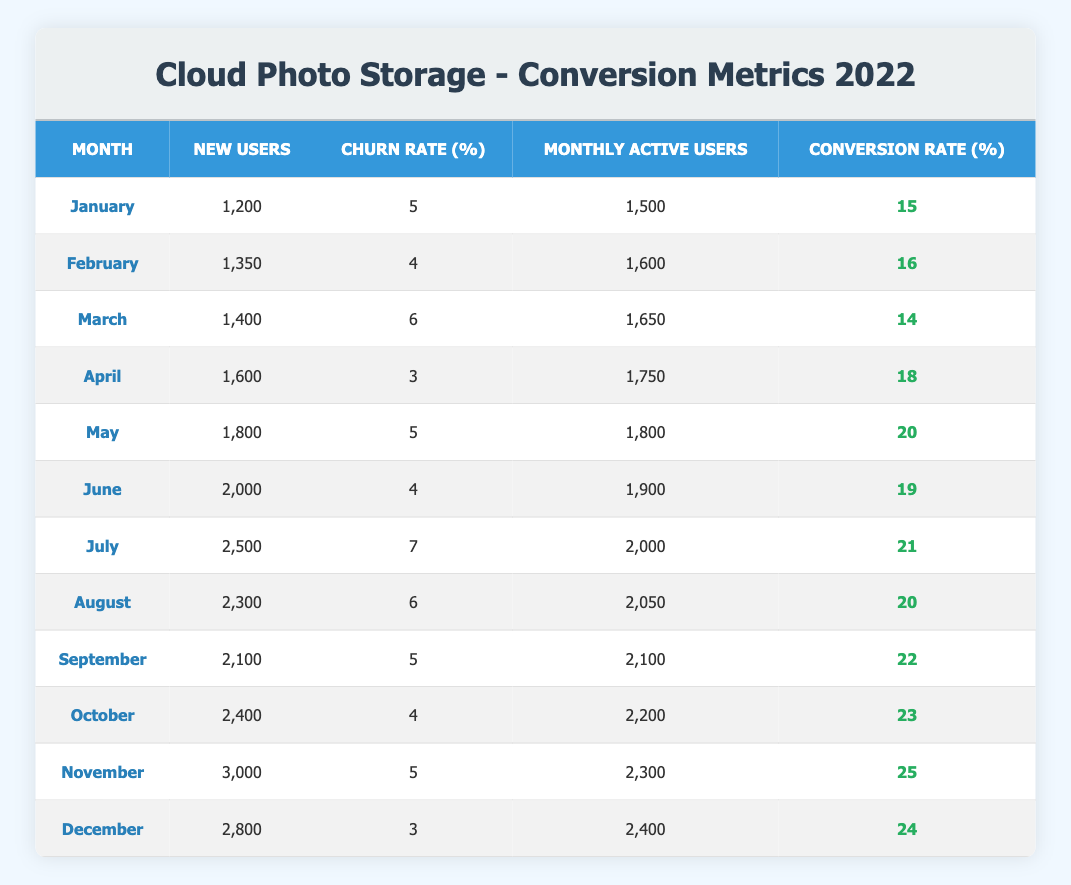What was the churn rate in July? From the table, the churn rate for July is listed directly in the corresponding row, which shows a value of 7.
Answer: 7 How many new users were acquired in November? The table specifies the number of new users acquired in November directly, which is 3,000.
Answer: 3,000 What was the average monthly active users from January to March? The monthly active users from January to March are 1,500, 1,600, and 1,650 respectively. To find the average, add these values (1,500 + 1,600 + 1,650 = 4,750) and divide by 3, resulting in an average of 1,583.33.
Answer: 1,583.33 Did the conversion rate exceed 20% in any month? By inspecting the conversion rates for each month in the table, it’s found that the conversion rates in July (21), November (25), and October (23) exceed 20%. Therefore, the answer is yes.
Answer: Yes What was the total number of new users acquired from April to June? The new users acquired in April, May, and June are 1,600, 1,800, and 2,000, respectively. To find the total, sum these values: 1,600 + 1,800 + 2,000 = 5,400.
Answer: 5,400 Which month had the highest conversion rate and what was that rate? Reviewing the table, November shows the highest conversion rate at 25% among all months listed.
Answer: November, 25 Was there a month when the churn rate was below 4%? The table indicates that the lowest churn rate recorded was 3% in April and December. Thus, the answer is yes.
Answer: Yes Calculate the difference in new users between January and December. From the table, January had 1,200 new users and December had 2,800 new users. The difference is calculated by subtracting January's value from December's (2,800 - 1,200 = 1,600).
Answer: 1,600 What was the conversion rate in the month with the lowest churn rate? The lowest churn rate occurred in April at 3%. Referring to the entry for April, the conversion rate during that month was 18%.
Answer: 18 